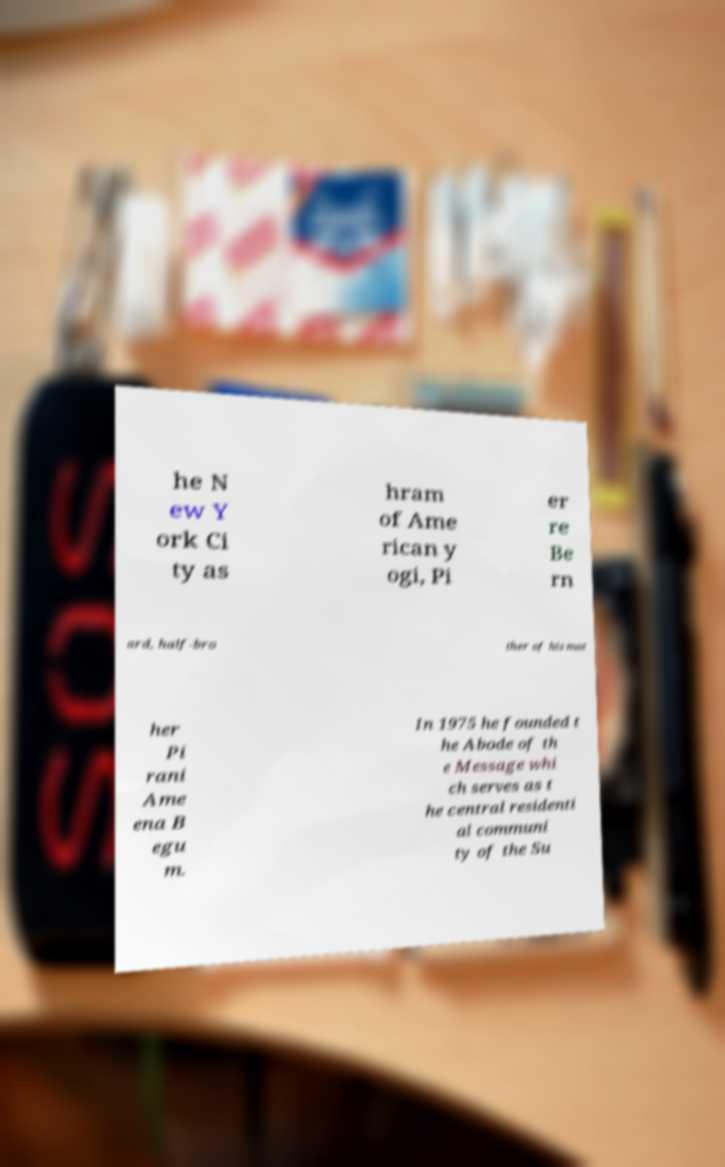What messages or text are displayed in this image? I need them in a readable, typed format. he N ew Y ork Ci ty as hram of Ame rican y ogi, Pi er re Be rn ard, half-bro ther of his mot her Pi rani Ame ena B egu m. In 1975 he founded t he Abode of th e Message whi ch serves as t he central residenti al communi ty of the Su 